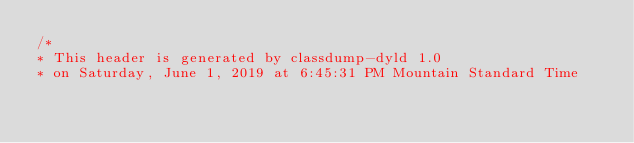<code> <loc_0><loc_0><loc_500><loc_500><_C_>/*
* This header is generated by classdump-dyld 1.0
* on Saturday, June 1, 2019 at 6:45:31 PM Mountain Standard Time</code> 